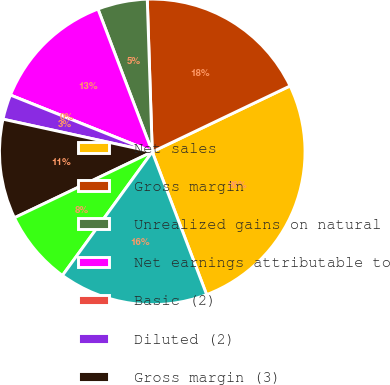Convert chart to OTSL. <chart><loc_0><loc_0><loc_500><loc_500><pie_chart><fcel>Net sales<fcel>Gross margin<fcel>Unrealized gains on natural<fcel>Net earnings attributable to<fcel>Basic (2)<fcel>Diluted (2)<fcel>Gross margin (3)<fcel>Unrealized (losses) gains on<fcel>Net (loss) earnings<nl><fcel>26.31%<fcel>18.42%<fcel>5.26%<fcel>13.16%<fcel>0.0%<fcel>2.63%<fcel>10.53%<fcel>7.9%<fcel>15.79%<nl></chart> 